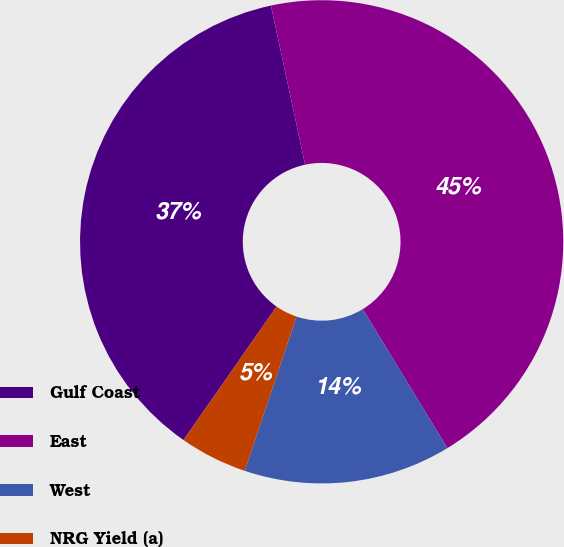Convert chart to OTSL. <chart><loc_0><loc_0><loc_500><loc_500><pie_chart><fcel>Gulf Coast<fcel>East<fcel>West<fcel>NRG Yield (a)<nl><fcel>36.95%<fcel>44.65%<fcel>13.87%<fcel>4.53%<nl></chart> 